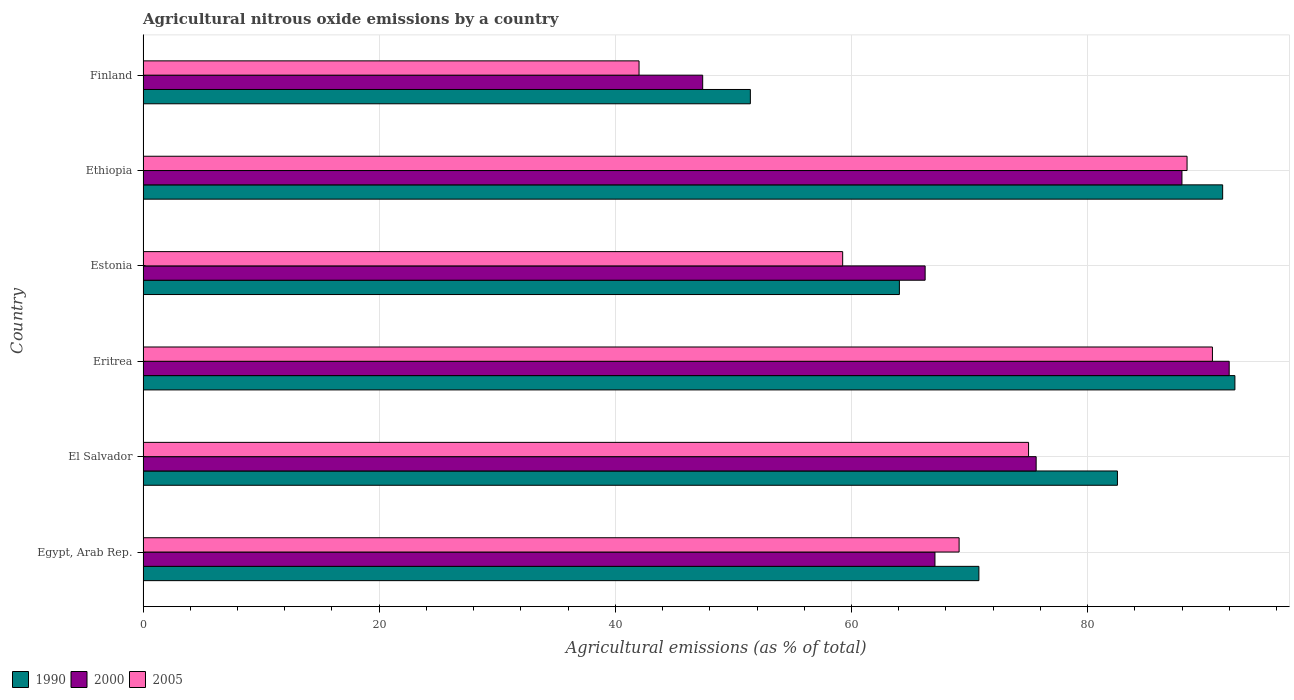Are the number of bars on each tick of the Y-axis equal?
Your answer should be compact. Yes. How many bars are there on the 5th tick from the top?
Your response must be concise. 3. What is the label of the 3rd group of bars from the top?
Keep it short and to the point. Estonia. In how many cases, is the number of bars for a given country not equal to the number of legend labels?
Offer a very short reply. 0. What is the amount of agricultural nitrous oxide emitted in 1990 in Estonia?
Offer a very short reply. 64.06. Across all countries, what is the maximum amount of agricultural nitrous oxide emitted in 1990?
Your answer should be very brief. 92.47. Across all countries, what is the minimum amount of agricultural nitrous oxide emitted in 2005?
Make the answer very short. 42.01. In which country was the amount of agricultural nitrous oxide emitted in 2005 maximum?
Your answer should be very brief. Eritrea. What is the total amount of agricultural nitrous oxide emitted in 2005 in the graph?
Keep it short and to the point. 424.35. What is the difference between the amount of agricultural nitrous oxide emitted in 1990 in El Salvador and that in Ethiopia?
Keep it short and to the point. -8.91. What is the difference between the amount of agricultural nitrous oxide emitted in 2005 in Eritrea and the amount of agricultural nitrous oxide emitted in 1990 in Estonia?
Provide a succinct answer. 26.51. What is the average amount of agricultural nitrous oxide emitted in 2000 per country?
Provide a succinct answer. 72.72. What is the difference between the amount of agricultural nitrous oxide emitted in 2000 and amount of agricultural nitrous oxide emitted in 1990 in Estonia?
Keep it short and to the point. 2.18. In how many countries, is the amount of agricultural nitrous oxide emitted in 2000 greater than 92 %?
Ensure brevity in your answer.  0. What is the ratio of the amount of agricultural nitrous oxide emitted in 2005 in Egypt, Arab Rep. to that in El Salvador?
Keep it short and to the point. 0.92. Is the difference between the amount of agricultural nitrous oxide emitted in 2000 in Egypt, Arab Rep. and Estonia greater than the difference between the amount of agricultural nitrous oxide emitted in 1990 in Egypt, Arab Rep. and Estonia?
Offer a very short reply. No. What is the difference between the highest and the second highest amount of agricultural nitrous oxide emitted in 1990?
Keep it short and to the point. 1.04. What is the difference between the highest and the lowest amount of agricultural nitrous oxide emitted in 2000?
Offer a very short reply. 44.59. How many bars are there?
Keep it short and to the point. 18. Does the graph contain grids?
Offer a terse response. Yes. Where does the legend appear in the graph?
Your answer should be very brief. Bottom left. What is the title of the graph?
Ensure brevity in your answer.  Agricultural nitrous oxide emissions by a country. Does "1974" appear as one of the legend labels in the graph?
Your answer should be compact. No. What is the label or title of the X-axis?
Make the answer very short. Agricultural emissions (as % of total). What is the Agricultural emissions (as % of total) of 1990 in Egypt, Arab Rep.?
Your response must be concise. 70.79. What is the Agricultural emissions (as % of total) in 2000 in Egypt, Arab Rep.?
Make the answer very short. 67.07. What is the Agricultural emissions (as % of total) of 2005 in Egypt, Arab Rep.?
Provide a short and direct response. 69.11. What is the Agricultural emissions (as % of total) of 1990 in El Salvador?
Your answer should be compact. 82.52. What is the Agricultural emissions (as % of total) of 2000 in El Salvador?
Provide a succinct answer. 75.64. What is the Agricultural emissions (as % of total) in 2005 in El Salvador?
Make the answer very short. 74.99. What is the Agricultural emissions (as % of total) in 1990 in Eritrea?
Give a very brief answer. 92.47. What is the Agricultural emissions (as % of total) of 2000 in Eritrea?
Keep it short and to the point. 91.99. What is the Agricultural emissions (as % of total) in 2005 in Eritrea?
Provide a short and direct response. 90.57. What is the Agricultural emissions (as % of total) in 1990 in Estonia?
Ensure brevity in your answer.  64.06. What is the Agricultural emissions (as % of total) of 2000 in Estonia?
Ensure brevity in your answer.  66.24. What is the Agricultural emissions (as % of total) in 2005 in Estonia?
Provide a succinct answer. 59.25. What is the Agricultural emissions (as % of total) in 1990 in Ethiopia?
Ensure brevity in your answer.  91.43. What is the Agricultural emissions (as % of total) in 2000 in Ethiopia?
Keep it short and to the point. 87.99. What is the Agricultural emissions (as % of total) of 2005 in Ethiopia?
Your answer should be compact. 88.42. What is the Agricultural emissions (as % of total) of 1990 in Finland?
Your response must be concise. 51.43. What is the Agricultural emissions (as % of total) in 2000 in Finland?
Offer a terse response. 47.4. What is the Agricultural emissions (as % of total) in 2005 in Finland?
Your response must be concise. 42.01. Across all countries, what is the maximum Agricultural emissions (as % of total) in 1990?
Keep it short and to the point. 92.47. Across all countries, what is the maximum Agricultural emissions (as % of total) of 2000?
Give a very brief answer. 91.99. Across all countries, what is the maximum Agricultural emissions (as % of total) of 2005?
Provide a succinct answer. 90.57. Across all countries, what is the minimum Agricultural emissions (as % of total) in 1990?
Provide a short and direct response. 51.43. Across all countries, what is the minimum Agricultural emissions (as % of total) of 2000?
Provide a short and direct response. 47.4. Across all countries, what is the minimum Agricultural emissions (as % of total) in 2005?
Give a very brief answer. 42.01. What is the total Agricultural emissions (as % of total) of 1990 in the graph?
Ensure brevity in your answer.  452.7. What is the total Agricultural emissions (as % of total) in 2000 in the graph?
Your answer should be very brief. 436.31. What is the total Agricultural emissions (as % of total) of 2005 in the graph?
Give a very brief answer. 424.35. What is the difference between the Agricultural emissions (as % of total) in 1990 in Egypt, Arab Rep. and that in El Salvador?
Provide a short and direct response. -11.73. What is the difference between the Agricultural emissions (as % of total) in 2000 in Egypt, Arab Rep. and that in El Salvador?
Ensure brevity in your answer.  -8.57. What is the difference between the Agricultural emissions (as % of total) in 2005 in Egypt, Arab Rep. and that in El Salvador?
Your answer should be compact. -5.88. What is the difference between the Agricultural emissions (as % of total) in 1990 in Egypt, Arab Rep. and that in Eritrea?
Offer a very short reply. -21.68. What is the difference between the Agricultural emissions (as % of total) in 2000 in Egypt, Arab Rep. and that in Eritrea?
Offer a very short reply. -24.92. What is the difference between the Agricultural emissions (as % of total) in 2005 in Egypt, Arab Rep. and that in Eritrea?
Provide a succinct answer. -21.46. What is the difference between the Agricultural emissions (as % of total) of 1990 in Egypt, Arab Rep. and that in Estonia?
Your answer should be compact. 6.73. What is the difference between the Agricultural emissions (as % of total) of 2000 in Egypt, Arab Rep. and that in Estonia?
Keep it short and to the point. 0.83. What is the difference between the Agricultural emissions (as % of total) in 2005 in Egypt, Arab Rep. and that in Estonia?
Your answer should be very brief. 9.86. What is the difference between the Agricultural emissions (as % of total) in 1990 in Egypt, Arab Rep. and that in Ethiopia?
Provide a succinct answer. -20.65. What is the difference between the Agricultural emissions (as % of total) in 2000 in Egypt, Arab Rep. and that in Ethiopia?
Provide a succinct answer. -20.92. What is the difference between the Agricultural emissions (as % of total) in 2005 in Egypt, Arab Rep. and that in Ethiopia?
Your response must be concise. -19.31. What is the difference between the Agricultural emissions (as % of total) in 1990 in Egypt, Arab Rep. and that in Finland?
Your response must be concise. 19.35. What is the difference between the Agricultural emissions (as % of total) in 2000 in Egypt, Arab Rep. and that in Finland?
Make the answer very short. 19.67. What is the difference between the Agricultural emissions (as % of total) of 2005 in Egypt, Arab Rep. and that in Finland?
Keep it short and to the point. 27.11. What is the difference between the Agricultural emissions (as % of total) in 1990 in El Salvador and that in Eritrea?
Your answer should be very brief. -9.95. What is the difference between the Agricultural emissions (as % of total) in 2000 in El Salvador and that in Eritrea?
Give a very brief answer. -16.35. What is the difference between the Agricultural emissions (as % of total) of 2005 in El Salvador and that in Eritrea?
Offer a terse response. -15.57. What is the difference between the Agricultural emissions (as % of total) in 1990 in El Salvador and that in Estonia?
Your answer should be very brief. 18.47. What is the difference between the Agricultural emissions (as % of total) in 2000 in El Salvador and that in Estonia?
Ensure brevity in your answer.  9.4. What is the difference between the Agricultural emissions (as % of total) of 2005 in El Salvador and that in Estonia?
Provide a succinct answer. 15.74. What is the difference between the Agricultural emissions (as % of total) in 1990 in El Salvador and that in Ethiopia?
Your answer should be very brief. -8.91. What is the difference between the Agricultural emissions (as % of total) in 2000 in El Salvador and that in Ethiopia?
Your answer should be very brief. -12.35. What is the difference between the Agricultural emissions (as % of total) of 2005 in El Salvador and that in Ethiopia?
Your answer should be very brief. -13.42. What is the difference between the Agricultural emissions (as % of total) of 1990 in El Salvador and that in Finland?
Your answer should be very brief. 31.09. What is the difference between the Agricultural emissions (as % of total) in 2000 in El Salvador and that in Finland?
Provide a succinct answer. 28.24. What is the difference between the Agricultural emissions (as % of total) of 2005 in El Salvador and that in Finland?
Your answer should be very brief. 32.99. What is the difference between the Agricultural emissions (as % of total) in 1990 in Eritrea and that in Estonia?
Your answer should be very brief. 28.41. What is the difference between the Agricultural emissions (as % of total) in 2000 in Eritrea and that in Estonia?
Give a very brief answer. 25.75. What is the difference between the Agricultural emissions (as % of total) of 2005 in Eritrea and that in Estonia?
Ensure brevity in your answer.  31.32. What is the difference between the Agricultural emissions (as % of total) of 1990 in Eritrea and that in Ethiopia?
Offer a very short reply. 1.04. What is the difference between the Agricultural emissions (as % of total) of 2000 in Eritrea and that in Ethiopia?
Provide a succinct answer. 4. What is the difference between the Agricultural emissions (as % of total) in 2005 in Eritrea and that in Ethiopia?
Your answer should be compact. 2.15. What is the difference between the Agricultural emissions (as % of total) of 1990 in Eritrea and that in Finland?
Keep it short and to the point. 41.04. What is the difference between the Agricultural emissions (as % of total) of 2000 in Eritrea and that in Finland?
Your response must be concise. 44.59. What is the difference between the Agricultural emissions (as % of total) of 2005 in Eritrea and that in Finland?
Provide a short and direct response. 48.56. What is the difference between the Agricultural emissions (as % of total) in 1990 in Estonia and that in Ethiopia?
Ensure brevity in your answer.  -27.38. What is the difference between the Agricultural emissions (as % of total) in 2000 in Estonia and that in Ethiopia?
Ensure brevity in your answer.  -21.75. What is the difference between the Agricultural emissions (as % of total) in 2005 in Estonia and that in Ethiopia?
Make the answer very short. -29.17. What is the difference between the Agricultural emissions (as % of total) of 1990 in Estonia and that in Finland?
Offer a very short reply. 12.62. What is the difference between the Agricultural emissions (as % of total) of 2000 in Estonia and that in Finland?
Your answer should be compact. 18.84. What is the difference between the Agricultural emissions (as % of total) of 2005 in Estonia and that in Finland?
Your response must be concise. 17.25. What is the difference between the Agricultural emissions (as % of total) in 1990 in Ethiopia and that in Finland?
Make the answer very short. 40. What is the difference between the Agricultural emissions (as % of total) of 2000 in Ethiopia and that in Finland?
Offer a terse response. 40.59. What is the difference between the Agricultural emissions (as % of total) in 2005 in Ethiopia and that in Finland?
Provide a succinct answer. 46.41. What is the difference between the Agricultural emissions (as % of total) in 1990 in Egypt, Arab Rep. and the Agricultural emissions (as % of total) in 2000 in El Salvador?
Offer a very short reply. -4.85. What is the difference between the Agricultural emissions (as % of total) of 1990 in Egypt, Arab Rep. and the Agricultural emissions (as % of total) of 2005 in El Salvador?
Provide a succinct answer. -4.21. What is the difference between the Agricultural emissions (as % of total) in 2000 in Egypt, Arab Rep. and the Agricultural emissions (as % of total) in 2005 in El Salvador?
Offer a terse response. -7.93. What is the difference between the Agricultural emissions (as % of total) of 1990 in Egypt, Arab Rep. and the Agricultural emissions (as % of total) of 2000 in Eritrea?
Your answer should be very brief. -21.2. What is the difference between the Agricultural emissions (as % of total) in 1990 in Egypt, Arab Rep. and the Agricultural emissions (as % of total) in 2005 in Eritrea?
Provide a succinct answer. -19.78. What is the difference between the Agricultural emissions (as % of total) in 2000 in Egypt, Arab Rep. and the Agricultural emissions (as % of total) in 2005 in Eritrea?
Offer a terse response. -23.5. What is the difference between the Agricultural emissions (as % of total) of 1990 in Egypt, Arab Rep. and the Agricultural emissions (as % of total) of 2000 in Estonia?
Ensure brevity in your answer.  4.55. What is the difference between the Agricultural emissions (as % of total) of 1990 in Egypt, Arab Rep. and the Agricultural emissions (as % of total) of 2005 in Estonia?
Provide a succinct answer. 11.54. What is the difference between the Agricultural emissions (as % of total) of 2000 in Egypt, Arab Rep. and the Agricultural emissions (as % of total) of 2005 in Estonia?
Offer a terse response. 7.82. What is the difference between the Agricultural emissions (as % of total) of 1990 in Egypt, Arab Rep. and the Agricultural emissions (as % of total) of 2000 in Ethiopia?
Ensure brevity in your answer.  -17.2. What is the difference between the Agricultural emissions (as % of total) of 1990 in Egypt, Arab Rep. and the Agricultural emissions (as % of total) of 2005 in Ethiopia?
Provide a succinct answer. -17.63. What is the difference between the Agricultural emissions (as % of total) in 2000 in Egypt, Arab Rep. and the Agricultural emissions (as % of total) in 2005 in Ethiopia?
Give a very brief answer. -21.35. What is the difference between the Agricultural emissions (as % of total) of 1990 in Egypt, Arab Rep. and the Agricultural emissions (as % of total) of 2000 in Finland?
Ensure brevity in your answer.  23.39. What is the difference between the Agricultural emissions (as % of total) in 1990 in Egypt, Arab Rep. and the Agricultural emissions (as % of total) in 2005 in Finland?
Your answer should be very brief. 28.78. What is the difference between the Agricultural emissions (as % of total) of 2000 in Egypt, Arab Rep. and the Agricultural emissions (as % of total) of 2005 in Finland?
Provide a short and direct response. 25.06. What is the difference between the Agricultural emissions (as % of total) of 1990 in El Salvador and the Agricultural emissions (as % of total) of 2000 in Eritrea?
Your response must be concise. -9.46. What is the difference between the Agricultural emissions (as % of total) of 1990 in El Salvador and the Agricultural emissions (as % of total) of 2005 in Eritrea?
Your response must be concise. -8.05. What is the difference between the Agricultural emissions (as % of total) of 2000 in El Salvador and the Agricultural emissions (as % of total) of 2005 in Eritrea?
Provide a short and direct response. -14.93. What is the difference between the Agricultural emissions (as % of total) of 1990 in El Salvador and the Agricultural emissions (as % of total) of 2000 in Estonia?
Your response must be concise. 16.29. What is the difference between the Agricultural emissions (as % of total) in 1990 in El Salvador and the Agricultural emissions (as % of total) in 2005 in Estonia?
Provide a succinct answer. 23.27. What is the difference between the Agricultural emissions (as % of total) in 2000 in El Salvador and the Agricultural emissions (as % of total) in 2005 in Estonia?
Your answer should be very brief. 16.39. What is the difference between the Agricultural emissions (as % of total) in 1990 in El Salvador and the Agricultural emissions (as % of total) in 2000 in Ethiopia?
Offer a terse response. -5.46. What is the difference between the Agricultural emissions (as % of total) in 1990 in El Salvador and the Agricultural emissions (as % of total) in 2005 in Ethiopia?
Make the answer very short. -5.9. What is the difference between the Agricultural emissions (as % of total) in 2000 in El Salvador and the Agricultural emissions (as % of total) in 2005 in Ethiopia?
Offer a terse response. -12.78. What is the difference between the Agricultural emissions (as % of total) in 1990 in El Salvador and the Agricultural emissions (as % of total) in 2000 in Finland?
Offer a terse response. 35.13. What is the difference between the Agricultural emissions (as % of total) of 1990 in El Salvador and the Agricultural emissions (as % of total) of 2005 in Finland?
Give a very brief answer. 40.52. What is the difference between the Agricultural emissions (as % of total) in 2000 in El Salvador and the Agricultural emissions (as % of total) in 2005 in Finland?
Keep it short and to the point. 33.63. What is the difference between the Agricultural emissions (as % of total) in 1990 in Eritrea and the Agricultural emissions (as % of total) in 2000 in Estonia?
Your answer should be very brief. 26.23. What is the difference between the Agricultural emissions (as % of total) in 1990 in Eritrea and the Agricultural emissions (as % of total) in 2005 in Estonia?
Give a very brief answer. 33.22. What is the difference between the Agricultural emissions (as % of total) of 2000 in Eritrea and the Agricultural emissions (as % of total) of 2005 in Estonia?
Offer a very short reply. 32.74. What is the difference between the Agricultural emissions (as % of total) of 1990 in Eritrea and the Agricultural emissions (as % of total) of 2000 in Ethiopia?
Offer a very short reply. 4.48. What is the difference between the Agricultural emissions (as % of total) in 1990 in Eritrea and the Agricultural emissions (as % of total) in 2005 in Ethiopia?
Your response must be concise. 4.05. What is the difference between the Agricultural emissions (as % of total) of 2000 in Eritrea and the Agricultural emissions (as % of total) of 2005 in Ethiopia?
Keep it short and to the point. 3.57. What is the difference between the Agricultural emissions (as % of total) in 1990 in Eritrea and the Agricultural emissions (as % of total) in 2000 in Finland?
Your answer should be very brief. 45.07. What is the difference between the Agricultural emissions (as % of total) of 1990 in Eritrea and the Agricultural emissions (as % of total) of 2005 in Finland?
Offer a terse response. 50.46. What is the difference between the Agricultural emissions (as % of total) of 2000 in Eritrea and the Agricultural emissions (as % of total) of 2005 in Finland?
Offer a terse response. 49.98. What is the difference between the Agricultural emissions (as % of total) of 1990 in Estonia and the Agricultural emissions (as % of total) of 2000 in Ethiopia?
Keep it short and to the point. -23.93. What is the difference between the Agricultural emissions (as % of total) of 1990 in Estonia and the Agricultural emissions (as % of total) of 2005 in Ethiopia?
Ensure brevity in your answer.  -24.36. What is the difference between the Agricultural emissions (as % of total) of 2000 in Estonia and the Agricultural emissions (as % of total) of 2005 in Ethiopia?
Offer a terse response. -22.18. What is the difference between the Agricultural emissions (as % of total) of 1990 in Estonia and the Agricultural emissions (as % of total) of 2000 in Finland?
Give a very brief answer. 16.66. What is the difference between the Agricultural emissions (as % of total) in 1990 in Estonia and the Agricultural emissions (as % of total) in 2005 in Finland?
Give a very brief answer. 22.05. What is the difference between the Agricultural emissions (as % of total) of 2000 in Estonia and the Agricultural emissions (as % of total) of 2005 in Finland?
Make the answer very short. 24.23. What is the difference between the Agricultural emissions (as % of total) in 1990 in Ethiopia and the Agricultural emissions (as % of total) in 2000 in Finland?
Your answer should be compact. 44.04. What is the difference between the Agricultural emissions (as % of total) in 1990 in Ethiopia and the Agricultural emissions (as % of total) in 2005 in Finland?
Offer a very short reply. 49.43. What is the difference between the Agricultural emissions (as % of total) in 2000 in Ethiopia and the Agricultural emissions (as % of total) in 2005 in Finland?
Provide a succinct answer. 45.98. What is the average Agricultural emissions (as % of total) of 1990 per country?
Ensure brevity in your answer.  75.45. What is the average Agricultural emissions (as % of total) in 2000 per country?
Make the answer very short. 72.72. What is the average Agricultural emissions (as % of total) of 2005 per country?
Your response must be concise. 70.73. What is the difference between the Agricultural emissions (as % of total) of 1990 and Agricultural emissions (as % of total) of 2000 in Egypt, Arab Rep.?
Your answer should be compact. 3.72. What is the difference between the Agricultural emissions (as % of total) in 1990 and Agricultural emissions (as % of total) in 2005 in Egypt, Arab Rep.?
Ensure brevity in your answer.  1.68. What is the difference between the Agricultural emissions (as % of total) of 2000 and Agricultural emissions (as % of total) of 2005 in Egypt, Arab Rep.?
Provide a succinct answer. -2.05. What is the difference between the Agricultural emissions (as % of total) of 1990 and Agricultural emissions (as % of total) of 2000 in El Salvador?
Your answer should be very brief. 6.88. What is the difference between the Agricultural emissions (as % of total) in 1990 and Agricultural emissions (as % of total) in 2005 in El Salvador?
Offer a terse response. 7.53. What is the difference between the Agricultural emissions (as % of total) in 2000 and Agricultural emissions (as % of total) in 2005 in El Salvador?
Your answer should be very brief. 0.64. What is the difference between the Agricultural emissions (as % of total) in 1990 and Agricultural emissions (as % of total) in 2000 in Eritrea?
Your response must be concise. 0.48. What is the difference between the Agricultural emissions (as % of total) of 1990 and Agricultural emissions (as % of total) of 2005 in Eritrea?
Your answer should be compact. 1.9. What is the difference between the Agricultural emissions (as % of total) in 2000 and Agricultural emissions (as % of total) in 2005 in Eritrea?
Make the answer very short. 1.42. What is the difference between the Agricultural emissions (as % of total) of 1990 and Agricultural emissions (as % of total) of 2000 in Estonia?
Your response must be concise. -2.18. What is the difference between the Agricultural emissions (as % of total) of 1990 and Agricultural emissions (as % of total) of 2005 in Estonia?
Offer a very short reply. 4.8. What is the difference between the Agricultural emissions (as % of total) of 2000 and Agricultural emissions (as % of total) of 2005 in Estonia?
Make the answer very short. 6.98. What is the difference between the Agricultural emissions (as % of total) in 1990 and Agricultural emissions (as % of total) in 2000 in Ethiopia?
Your answer should be very brief. 3.45. What is the difference between the Agricultural emissions (as % of total) of 1990 and Agricultural emissions (as % of total) of 2005 in Ethiopia?
Keep it short and to the point. 3.02. What is the difference between the Agricultural emissions (as % of total) in 2000 and Agricultural emissions (as % of total) in 2005 in Ethiopia?
Provide a short and direct response. -0.43. What is the difference between the Agricultural emissions (as % of total) of 1990 and Agricultural emissions (as % of total) of 2000 in Finland?
Provide a short and direct response. 4.04. What is the difference between the Agricultural emissions (as % of total) of 1990 and Agricultural emissions (as % of total) of 2005 in Finland?
Ensure brevity in your answer.  9.43. What is the difference between the Agricultural emissions (as % of total) in 2000 and Agricultural emissions (as % of total) in 2005 in Finland?
Make the answer very short. 5.39. What is the ratio of the Agricultural emissions (as % of total) in 1990 in Egypt, Arab Rep. to that in El Salvador?
Offer a very short reply. 0.86. What is the ratio of the Agricultural emissions (as % of total) in 2000 in Egypt, Arab Rep. to that in El Salvador?
Give a very brief answer. 0.89. What is the ratio of the Agricultural emissions (as % of total) in 2005 in Egypt, Arab Rep. to that in El Salvador?
Make the answer very short. 0.92. What is the ratio of the Agricultural emissions (as % of total) in 1990 in Egypt, Arab Rep. to that in Eritrea?
Offer a very short reply. 0.77. What is the ratio of the Agricultural emissions (as % of total) of 2000 in Egypt, Arab Rep. to that in Eritrea?
Keep it short and to the point. 0.73. What is the ratio of the Agricultural emissions (as % of total) in 2005 in Egypt, Arab Rep. to that in Eritrea?
Provide a succinct answer. 0.76. What is the ratio of the Agricultural emissions (as % of total) in 1990 in Egypt, Arab Rep. to that in Estonia?
Give a very brief answer. 1.11. What is the ratio of the Agricultural emissions (as % of total) in 2000 in Egypt, Arab Rep. to that in Estonia?
Keep it short and to the point. 1.01. What is the ratio of the Agricultural emissions (as % of total) in 2005 in Egypt, Arab Rep. to that in Estonia?
Give a very brief answer. 1.17. What is the ratio of the Agricultural emissions (as % of total) in 1990 in Egypt, Arab Rep. to that in Ethiopia?
Your response must be concise. 0.77. What is the ratio of the Agricultural emissions (as % of total) of 2000 in Egypt, Arab Rep. to that in Ethiopia?
Your response must be concise. 0.76. What is the ratio of the Agricultural emissions (as % of total) in 2005 in Egypt, Arab Rep. to that in Ethiopia?
Your response must be concise. 0.78. What is the ratio of the Agricultural emissions (as % of total) in 1990 in Egypt, Arab Rep. to that in Finland?
Offer a very short reply. 1.38. What is the ratio of the Agricultural emissions (as % of total) in 2000 in Egypt, Arab Rep. to that in Finland?
Your answer should be compact. 1.42. What is the ratio of the Agricultural emissions (as % of total) of 2005 in Egypt, Arab Rep. to that in Finland?
Your answer should be very brief. 1.65. What is the ratio of the Agricultural emissions (as % of total) of 1990 in El Salvador to that in Eritrea?
Make the answer very short. 0.89. What is the ratio of the Agricultural emissions (as % of total) in 2000 in El Salvador to that in Eritrea?
Give a very brief answer. 0.82. What is the ratio of the Agricultural emissions (as % of total) in 2005 in El Salvador to that in Eritrea?
Ensure brevity in your answer.  0.83. What is the ratio of the Agricultural emissions (as % of total) of 1990 in El Salvador to that in Estonia?
Your answer should be compact. 1.29. What is the ratio of the Agricultural emissions (as % of total) in 2000 in El Salvador to that in Estonia?
Keep it short and to the point. 1.14. What is the ratio of the Agricultural emissions (as % of total) in 2005 in El Salvador to that in Estonia?
Offer a terse response. 1.27. What is the ratio of the Agricultural emissions (as % of total) in 1990 in El Salvador to that in Ethiopia?
Offer a terse response. 0.9. What is the ratio of the Agricultural emissions (as % of total) in 2000 in El Salvador to that in Ethiopia?
Keep it short and to the point. 0.86. What is the ratio of the Agricultural emissions (as % of total) of 2005 in El Salvador to that in Ethiopia?
Your answer should be very brief. 0.85. What is the ratio of the Agricultural emissions (as % of total) in 1990 in El Salvador to that in Finland?
Give a very brief answer. 1.6. What is the ratio of the Agricultural emissions (as % of total) of 2000 in El Salvador to that in Finland?
Ensure brevity in your answer.  1.6. What is the ratio of the Agricultural emissions (as % of total) in 2005 in El Salvador to that in Finland?
Provide a succinct answer. 1.79. What is the ratio of the Agricultural emissions (as % of total) of 1990 in Eritrea to that in Estonia?
Your answer should be compact. 1.44. What is the ratio of the Agricultural emissions (as % of total) of 2000 in Eritrea to that in Estonia?
Your response must be concise. 1.39. What is the ratio of the Agricultural emissions (as % of total) in 2005 in Eritrea to that in Estonia?
Offer a terse response. 1.53. What is the ratio of the Agricultural emissions (as % of total) of 1990 in Eritrea to that in Ethiopia?
Make the answer very short. 1.01. What is the ratio of the Agricultural emissions (as % of total) of 2000 in Eritrea to that in Ethiopia?
Your answer should be compact. 1.05. What is the ratio of the Agricultural emissions (as % of total) in 2005 in Eritrea to that in Ethiopia?
Provide a succinct answer. 1.02. What is the ratio of the Agricultural emissions (as % of total) of 1990 in Eritrea to that in Finland?
Ensure brevity in your answer.  1.8. What is the ratio of the Agricultural emissions (as % of total) in 2000 in Eritrea to that in Finland?
Make the answer very short. 1.94. What is the ratio of the Agricultural emissions (as % of total) of 2005 in Eritrea to that in Finland?
Provide a short and direct response. 2.16. What is the ratio of the Agricultural emissions (as % of total) of 1990 in Estonia to that in Ethiopia?
Your response must be concise. 0.7. What is the ratio of the Agricultural emissions (as % of total) in 2000 in Estonia to that in Ethiopia?
Offer a terse response. 0.75. What is the ratio of the Agricultural emissions (as % of total) in 2005 in Estonia to that in Ethiopia?
Your response must be concise. 0.67. What is the ratio of the Agricultural emissions (as % of total) in 1990 in Estonia to that in Finland?
Make the answer very short. 1.25. What is the ratio of the Agricultural emissions (as % of total) of 2000 in Estonia to that in Finland?
Offer a very short reply. 1.4. What is the ratio of the Agricultural emissions (as % of total) in 2005 in Estonia to that in Finland?
Your response must be concise. 1.41. What is the ratio of the Agricultural emissions (as % of total) of 1990 in Ethiopia to that in Finland?
Your answer should be compact. 1.78. What is the ratio of the Agricultural emissions (as % of total) of 2000 in Ethiopia to that in Finland?
Your answer should be very brief. 1.86. What is the ratio of the Agricultural emissions (as % of total) of 2005 in Ethiopia to that in Finland?
Your answer should be very brief. 2.1. What is the difference between the highest and the second highest Agricultural emissions (as % of total) in 1990?
Make the answer very short. 1.04. What is the difference between the highest and the second highest Agricultural emissions (as % of total) of 2000?
Make the answer very short. 4. What is the difference between the highest and the second highest Agricultural emissions (as % of total) in 2005?
Offer a very short reply. 2.15. What is the difference between the highest and the lowest Agricultural emissions (as % of total) of 1990?
Keep it short and to the point. 41.04. What is the difference between the highest and the lowest Agricultural emissions (as % of total) in 2000?
Provide a short and direct response. 44.59. What is the difference between the highest and the lowest Agricultural emissions (as % of total) of 2005?
Make the answer very short. 48.56. 